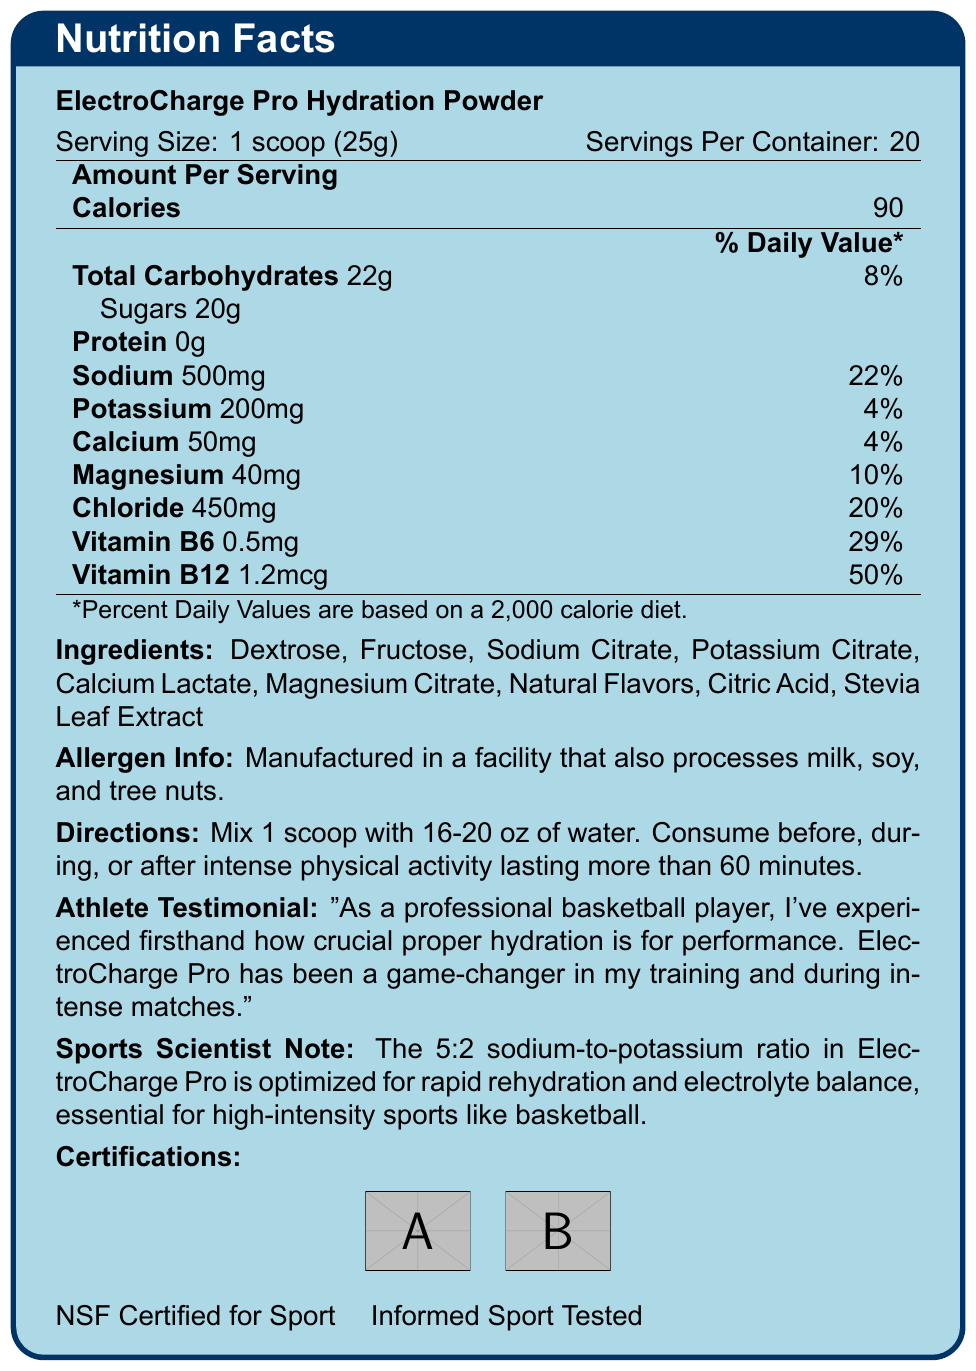what is the serving size? The serving size is mentioned at the beginning of the document as "Serving Size: 1 scoop (25g)".
Answer: 1 scoop (25g) how many servings are in the container? The document states "Servings Per Container: 20".
Answer: 20 how much sodium is in one serving? In the Amount Per Serving section, sodium is listed as 500mg per serving.
Answer: 500mg what is the sodium-to-potassium ratio? The Sports Scientist Note mentions that ElectroCharge Pro has a 5:2 sodium-to-potassium ratio.
Answer: 5:2 which vitamins are included in the hydration powder? The nutrition facts list includes Vitamin B6 and Vitamin B12.
Answer: Vitamin B6 and Vitamin B12 what are the total carbohydrates per serving? A. 20g B. 22g C. 18g D. 25g The document lists "Total Carbohydrates: 22g" under Amount Per Serving.
Answer: B. 22g what is the percent daily value of vitamin B12? A. 29% B. 22% C. 50% D. 10% The Amount Per Serving section lists the percent daily value of Vitamin B12 as "50%".
Answer: C. 50% is ElectroCharge Pro safe for someone with a tree nut allergy? The Allergen Info states "Manufactured in a facility that also processes milk, soy, and tree nuts."
Answer: No does the product contain any protein? The Amount Per Serving section shows Protein as "0g".
Answer: No summarize the main features of the ElectroCharge Pro Hydration Powder. The document presents detailed nutritional information, ingredients, directions for use, allergen information, athlete testimonials, and certifications, emphasizing its suitability for athletes.
Answer: ElectroCharge Pro is a sports hydration powder designed for optimal rehydration with a 5:2 sodium-to-potassium ratio, added minerals, and vitamins. It contains 90 calories per serving, with 20g of sugars and essential electrolytes like sodium, potassium, calcium, magnesium, and chloride. It's recommended for use before, during, or after intense physical activity and has certifications like NSF Certified for Sport and Informed Sport Tested. what is the athlete's testimony about the product? This quote is found in the Athlete Testimonial section.
Answer: The athlete says, "As a professional basketball player, I've experienced firsthand how crucial proper hydration is for performance. ElectroCharge Pro has been a game-changer in my training and during intense matches." who manufactures ElectroCharge Pro? The document does not provide information about the manufacturer of ElectroCharge Pro.
Answer: Not enough information how many calories are in a single serving of the hydration powder? The document lists "Calories: 90" under Amount Per Serving.
Answer: 90 calories what minerals are added to the ElectroCharge Pro Hydration Powder? The Amount Per Serving section lists Calcium, Magnesium, and Chloride among the nutritional values.
Answer: Calcium, Magnesium, Chloride what flavoring agent is used in the product? A. Salt B. Natural Flavors C. Artificial Flavors D. Sugar substitute The ingredient list includes "Natural Flavors".
Answer: B. Natural Flavors is the product certified for sport? The Certifications section includes "NSF Certified for Sport" and "Informed Sport Tested".
Answer: Yes how should the hydration powder be consumed? The Directions section provides the specific usage instructions.
Answer: Mix 1 scoop with 16-20 oz of water. Consume before, during, or after intense physical activity lasting more than 60 minutes. 